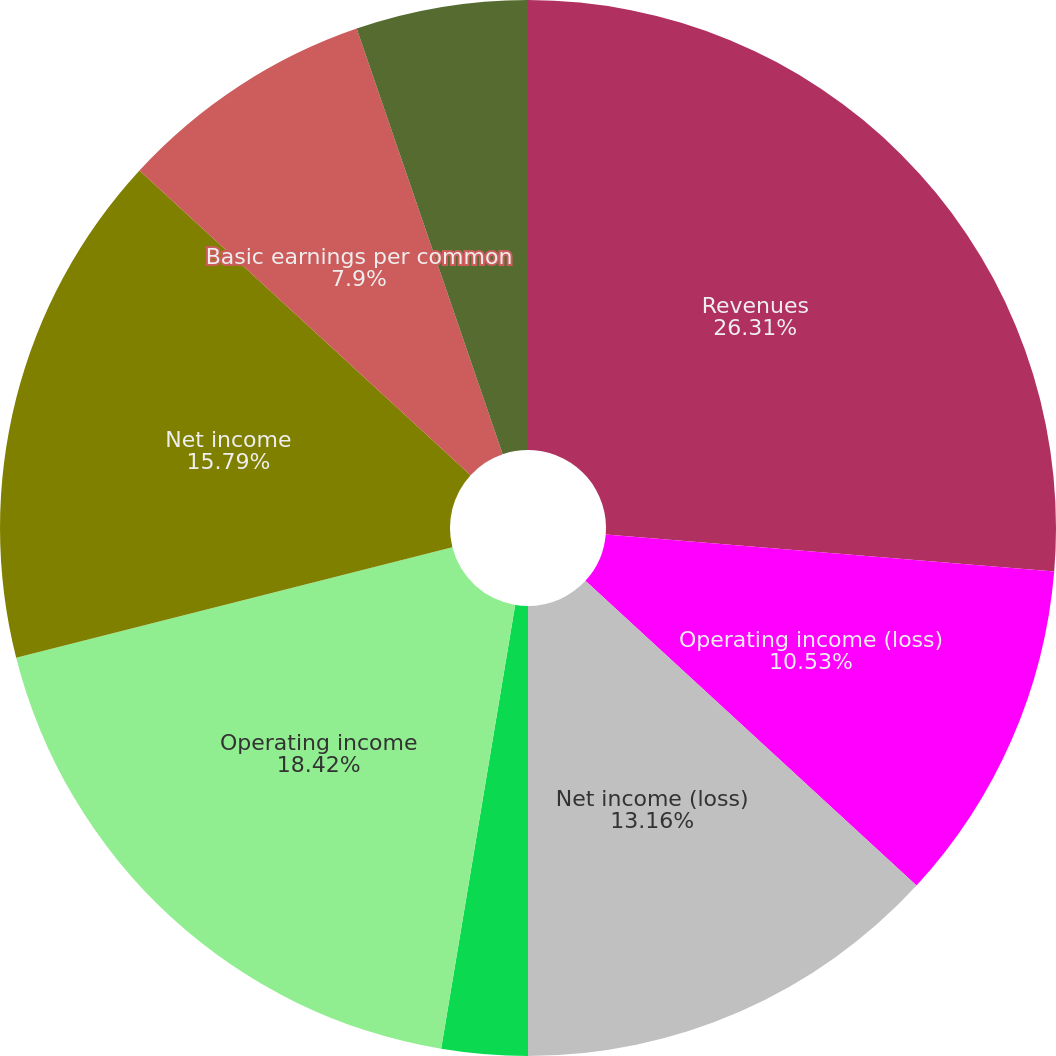Convert chart to OTSL. <chart><loc_0><loc_0><loc_500><loc_500><pie_chart><fcel>Revenues<fcel>Operating income (loss)<fcel>Net income (loss)<fcel>Basic earnings (loss) per<fcel>Diluted earnings (loss) per<fcel>Operating income<fcel>Net income<fcel>Basic earnings per common<fcel>Diluted earnings per common<nl><fcel>26.31%<fcel>10.53%<fcel>13.16%<fcel>0.0%<fcel>2.63%<fcel>18.42%<fcel>15.79%<fcel>7.9%<fcel>5.26%<nl></chart> 